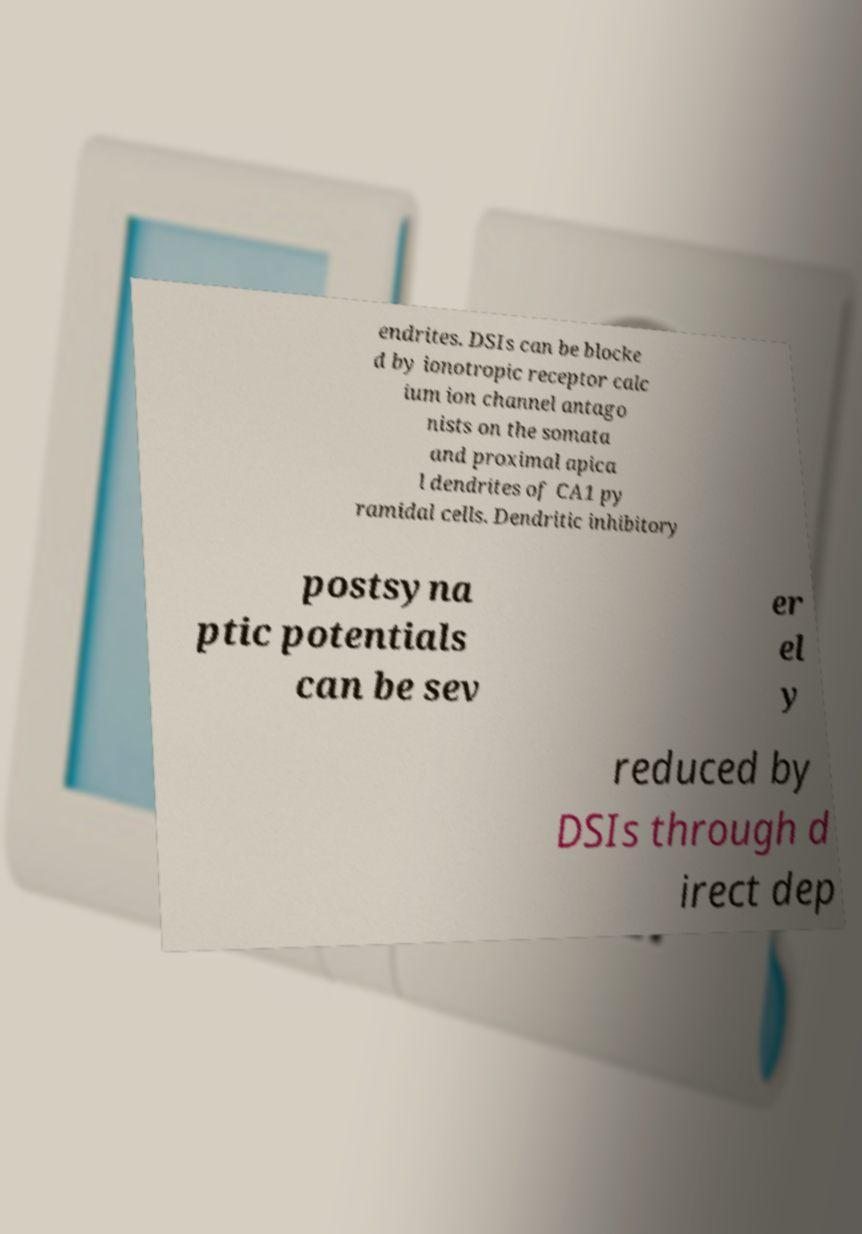Could you assist in decoding the text presented in this image and type it out clearly? endrites. DSIs can be blocke d by ionotropic receptor calc ium ion channel antago nists on the somata and proximal apica l dendrites of CA1 py ramidal cells. Dendritic inhibitory postsyna ptic potentials can be sev er el y reduced by DSIs through d irect dep 